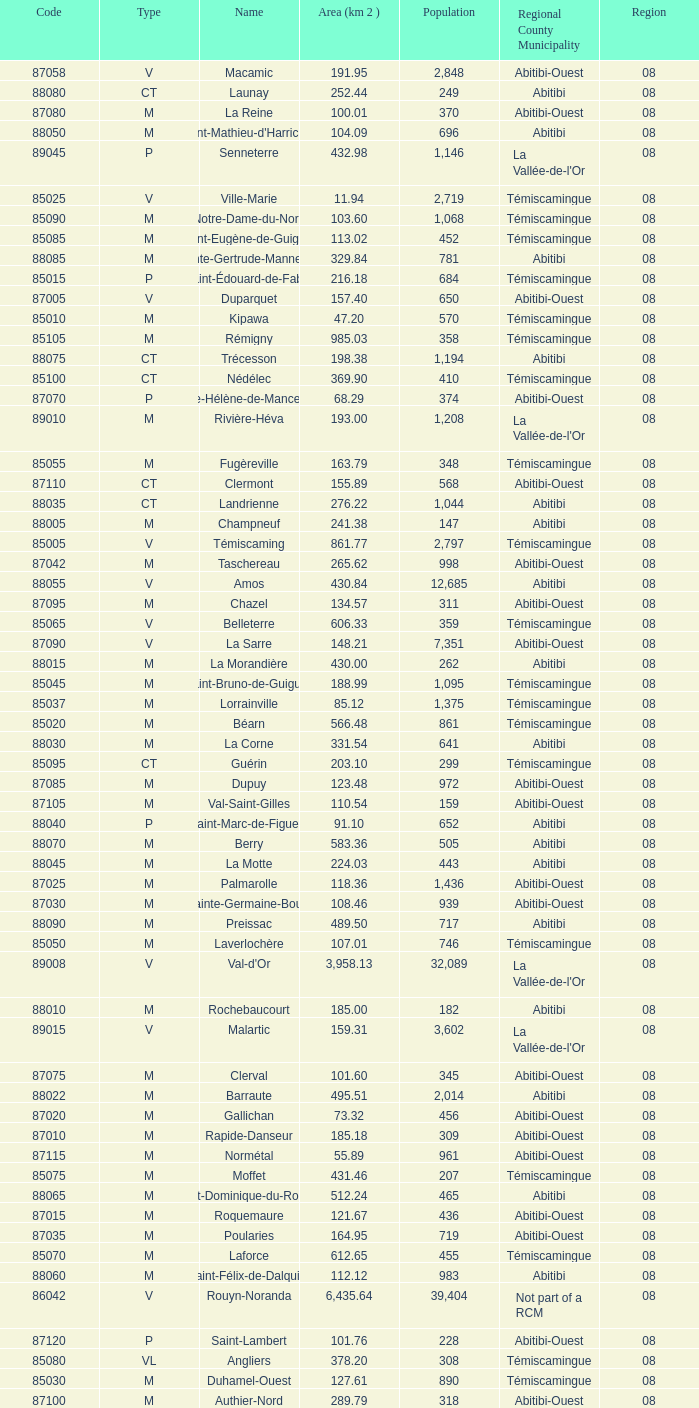What type has a population of 370? M. 